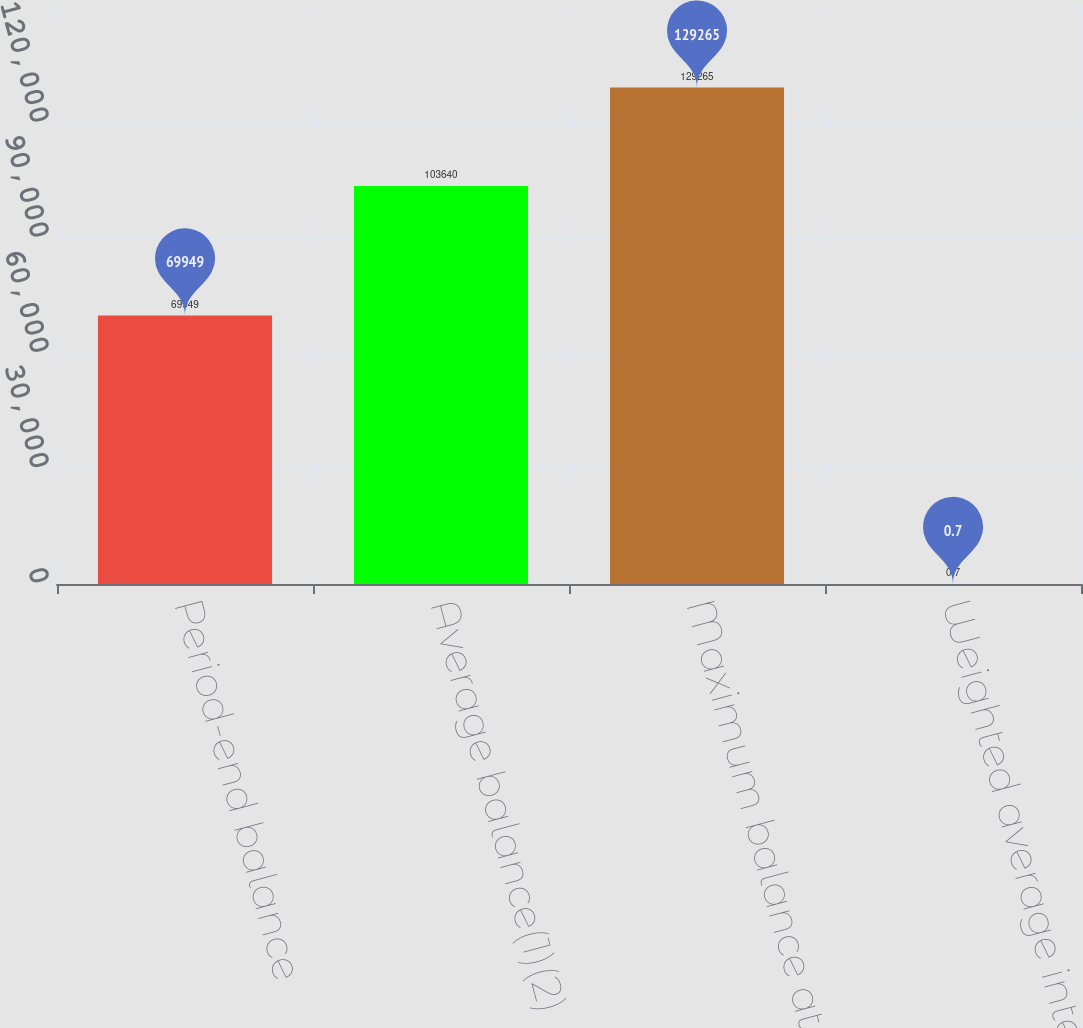Convert chart to OTSL. <chart><loc_0><loc_0><loc_500><loc_500><bar_chart><fcel>Period-end balance<fcel>Average balance(1)(2)<fcel>Maximum balance at any<fcel>Weighted average interest rate<nl><fcel>69949<fcel>103640<fcel>129265<fcel>0.7<nl></chart> 